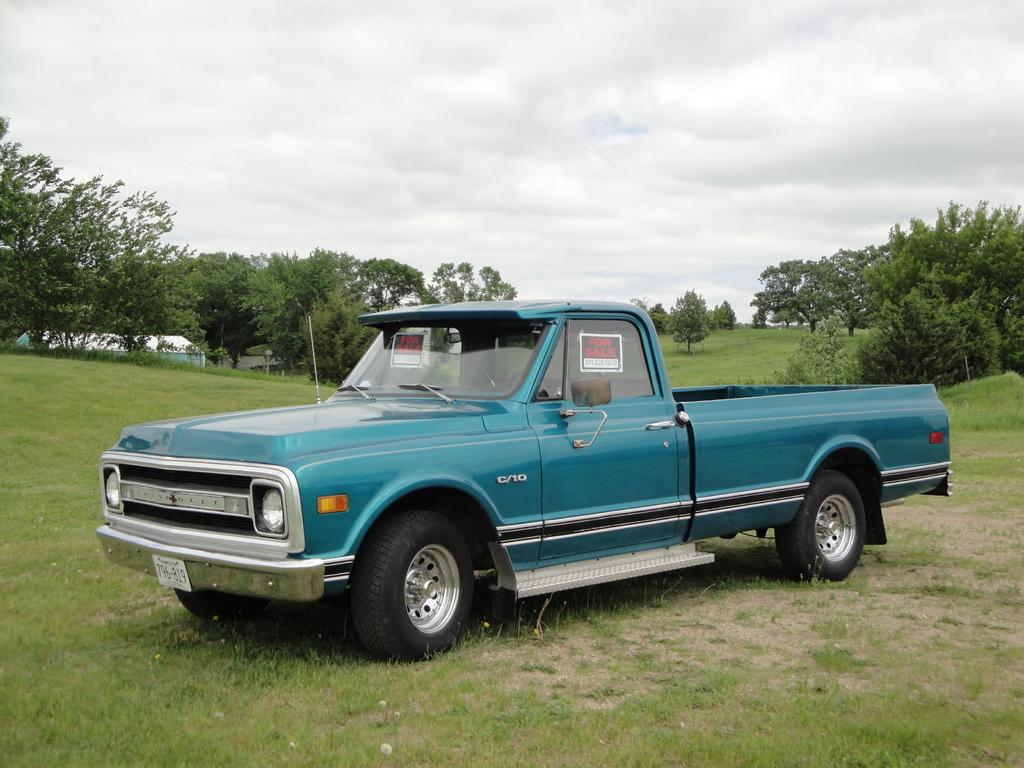What is the main subject in the foreground of the image? There is a vehicle in the foreground of the image. Where is the vehicle located? The vehicle is on the grass. What can be seen in the background of the image? There are trees, grassland, a house, and the sky visible in the background of the image. What type of instrument is being played by the person in the vehicle? There is no person visible in the vehicle, nor is there any indication of an instrument being played. 